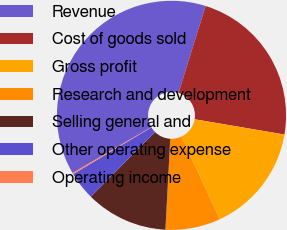Convert chart. <chart><loc_0><loc_0><loc_500><loc_500><pie_chart><fcel>Revenue<fcel>Cost of goods sold<fcel>Gross profit<fcel>Research and development<fcel>Selling general and<fcel>Other operating expense<fcel>Operating income<nl><fcel>38.22%<fcel>22.86%<fcel>15.39%<fcel>7.78%<fcel>11.59%<fcel>3.98%<fcel>0.18%<nl></chart> 